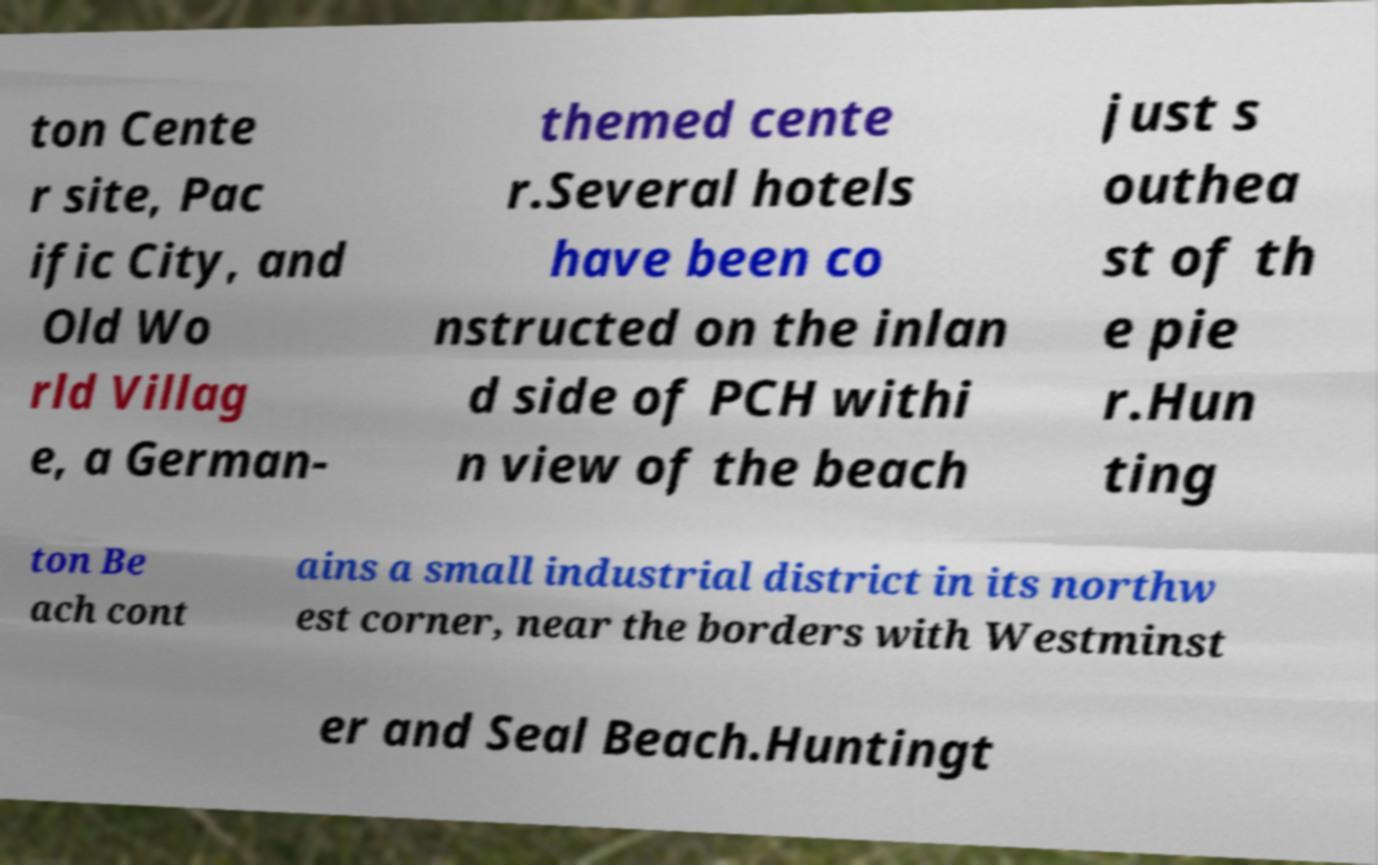Can you accurately transcribe the text from the provided image for me? ton Cente r site, Pac ific City, and Old Wo rld Villag e, a German- themed cente r.Several hotels have been co nstructed on the inlan d side of PCH withi n view of the beach just s outhea st of th e pie r.Hun ting ton Be ach cont ains a small industrial district in its northw est corner, near the borders with Westminst er and Seal Beach.Huntingt 